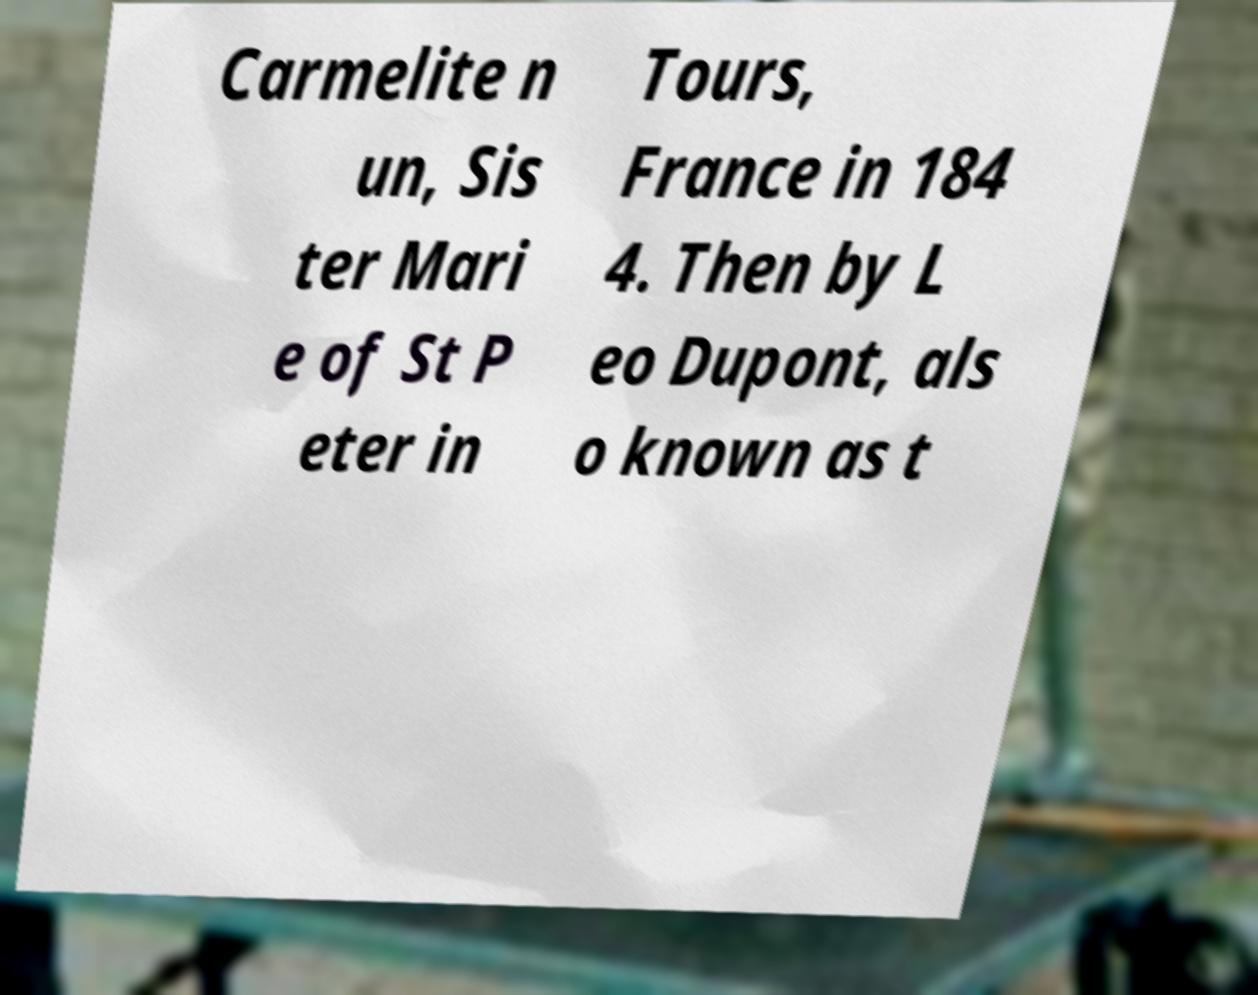Could you assist in decoding the text presented in this image and type it out clearly? Carmelite n un, Sis ter Mari e of St P eter in Tours, France in 184 4. Then by L eo Dupont, als o known as t 